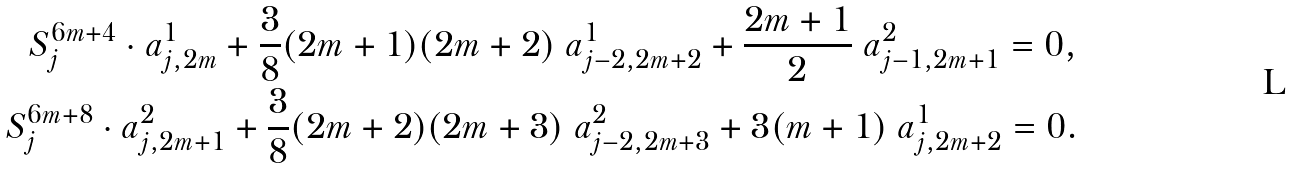<formula> <loc_0><loc_0><loc_500><loc_500>S ^ { 6 m + 4 } _ { j } \cdot a ^ { 1 } _ { j , 2 m } + \frac { 3 } { 8 } ( 2 m + 1 ) ( 2 m + 2 ) \ a ^ { 1 } _ { j - 2 , 2 m + 2 } + \frac { 2 m + 1 } { 2 } \ a ^ { 2 } _ { j - 1 , 2 m + 1 } = 0 , \\ S ^ { 6 m + 8 } _ { j } \cdot a ^ { 2 } _ { j , 2 m + 1 } + \frac { 3 } { 8 } ( 2 m + 2 ) ( 2 m + 3 ) \ a ^ { 2 } _ { j - 2 , 2 m + 3 } + 3 ( m + 1 ) \ a ^ { 1 } _ { j , 2 m + 2 } = 0 .</formula> 